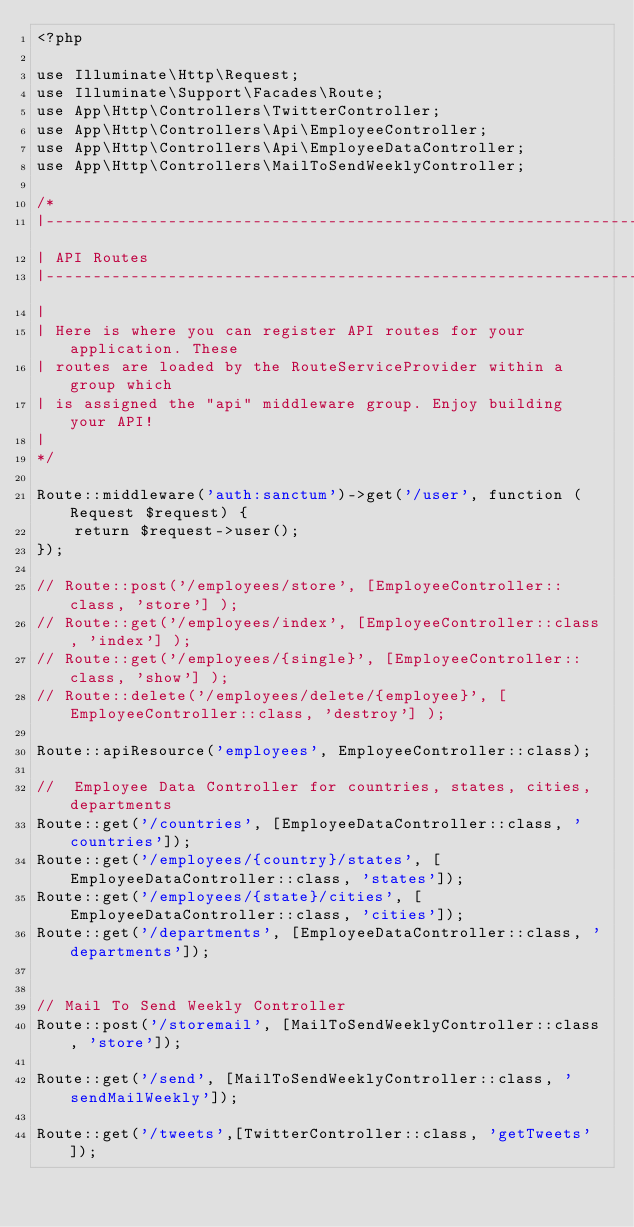<code> <loc_0><loc_0><loc_500><loc_500><_PHP_><?php

use Illuminate\Http\Request;
use Illuminate\Support\Facades\Route;
use App\Http\Controllers\TwitterController;
use App\Http\Controllers\Api\EmployeeController;
use App\Http\Controllers\Api\EmployeeDataController;
use App\Http\Controllers\MailToSendWeeklyController;

/*
|--------------------------------------------------------------------------
| API Routes
|--------------------------------------------------------------------------
|
| Here is where you can register API routes for your application. These
| routes are loaded by the RouteServiceProvider within a group which
| is assigned the "api" middleware group. Enjoy building your API!
|
*/

Route::middleware('auth:sanctum')->get('/user', function (Request $request) {
    return $request->user();
});

// Route::post('/employees/store', [EmployeeController::class, 'store'] );
// Route::get('/employees/index', [EmployeeController::class, 'index'] );
// Route::get('/employees/{single}', [EmployeeController::class, 'show'] );
// Route::delete('/employees/delete/{employee}', [EmployeeController::class, 'destroy'] );

Route::apiResource('employees', EmployeeController::class);

//  Employee Data Controller for countries, states, cities, departments
Route::get('/countries', [EmployeeDataController::class, 'countries']);
Route::get('/employees/{country}/states', [EmployeeDataController::class, 'states']);
Route::get('/employees/{state}/cities', [EmployeeDataController::class, 'cities']);
Route::get('/departments', [EmployeeDataController::class, 'departments']);


// Mail To Send Weekly Controller
Route::post('/storemail', [MailToSendWeeklyController::class, 'store']);

Route::get('/send', [MailToSendWeeklyController::class, 'sendMailWeekly']);

Route::get('/tweets',[TwitterController::class, 'getTweets']);</code> 